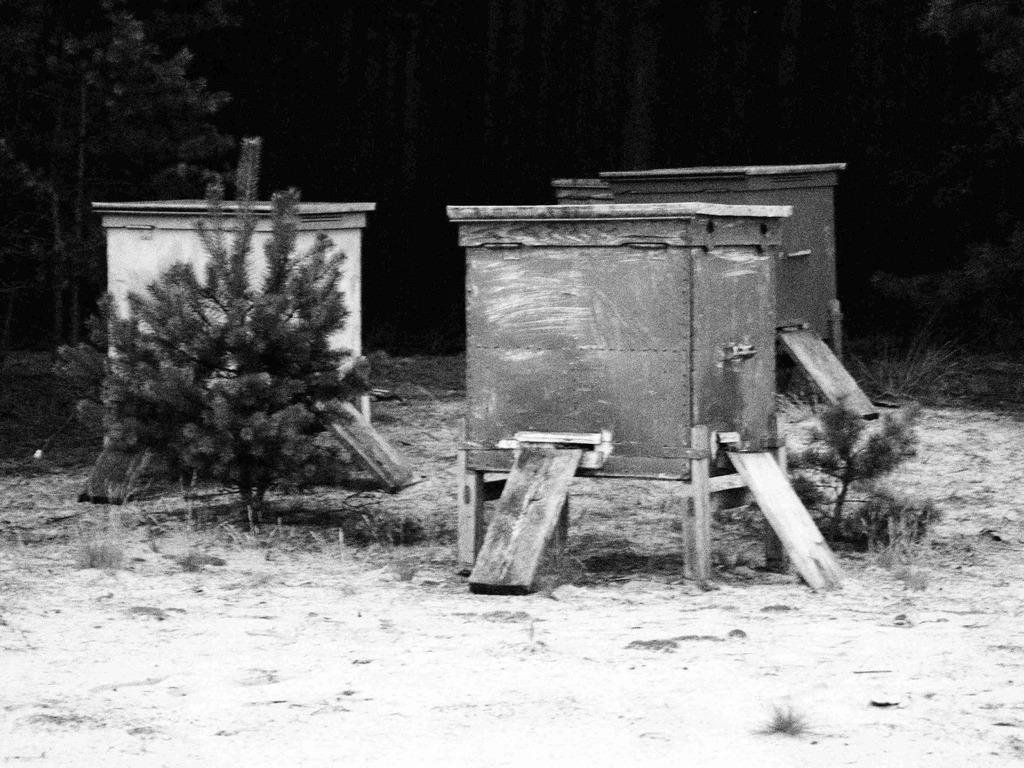What is the color scheme of the image? The image is black and white. What objects can be seen in the image? There are wooden boxes and plants in the image. What type of vegetation is present in the image? There are trees in the image. What can be seen in the background of the image? The sky in the background is dark. How many buttons are visible on the wooden boxes in the image? There are no buttons visible on the wooden boxes in the image. What type of sail can be seen in the image? There is no sail present in the image. 